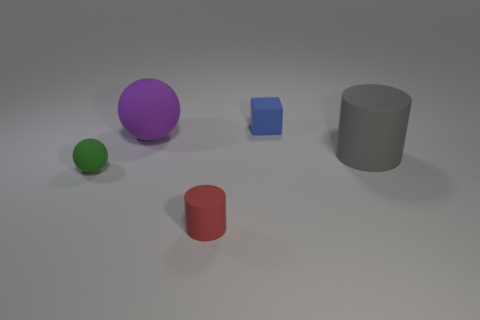Add 4 big red rubber cubes. How many objects exist? 9 Subtract all cylinders. How many objects are left? 3 Subtract all blue objects. Subtract all red matte things. How many objects are left? 3 Add 1 red rubber things. How many red rubber things are left? 2 Add 5 big gray objects. How many big gray objects exist? 6 Subtract 0 yellow balls. How many objects are left? 5 